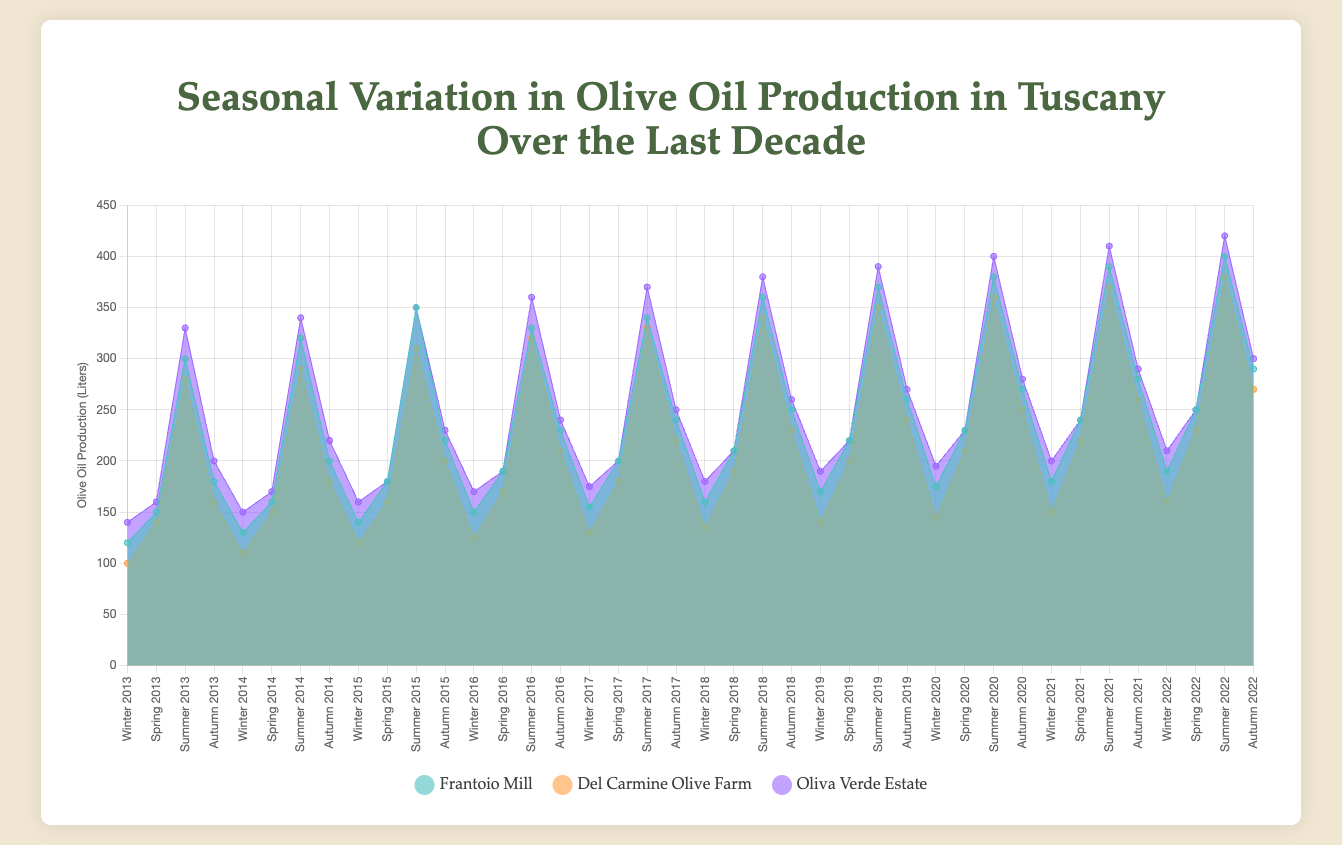What is the title of the chart? The title is displayed at the top of the chart area. It reads "Seasonal Variation in Olive Oil Production in Tuscany Over the Last Decade".
Answer: Seasonal Variation in Olive Oil Production in Tuscany Over the Last Decade Which olive farm had the highest production in Autumn 2022? Reviewing the chart, note the area corresponding to Autumn 2022 for each farm. The Oliva Verde Estate has the largest area for this period, indicating the highest production.
Answer: Oliva Verde Estate What are the axis labels in the chart? The x-axis has labels for each season-year combination (e.g., "Winter 2013"), and the y-axis is labeled "Olive Oil Production (Liters)".
Answer: Seasons and Years on x-axis, Olive Oil Production (Liters) on y-axis How does the olive oil production in Winter 2022 for Oliva Verde Estate compare to Winter 2013? To compare, locate the data points for Winter 2022 and Winter 2013 for Oliva Verde Estate. Winter 2022 has a production of 210 liters, while Winter 2013 has 140 liters, showing an increase.
Answer: Winter 2022 is higher by 70 liters Which season generally sees the highest olive oil production across all farms? Observing the seasonal patterns for each year, Summer consistently shows the highest production across all farms. The areas for Summer are repeatedly the largest.
Answer: Summer What was the average production in Summer over the last decade for Frantoio Mill? Sum the Summer values for each year (300 + 320 + 350 + 330 + 340 + 360 + 370 + 380 + 390 + 400 = 3540), then divide by the number of years (10).
Answer: 354 liters Between Del Carmine Olive Farm and Frantoio Mill, which had higher production in Spring 2017? Compare the Spring 2017 data points for both farms. Frantoio Mill produced 200 liters and Del Carmine Olive Farm produced 180 liters.
Answer: Frantoio Mill Compare the total production over the decade for Oliva Verde Estate and Del Carmine Olive Farm. Which one is higher? Sum all seasonal production values from 2013 to 2022 for both farms. For Oliva Verde Estate: 16200 liters; for Del Carmine Olive Farm: 11100 liters. Oliva Verde Estate has higher total production.
Answer: Oliva Verde Estate What trend is observed for the production at Frantoio Mill from 2013 to 2022? Reviewing Frantoio Mill's data from 2013 to 2022, we see a systematic increase in production across all seasons each subsequent year.
Answer: Increasing trend What is the median production in Spring for Del Carmine Olive Farm over the last decade? The Spring values are: 140, 150, 160, 170, 180, 190, 200, 210, 220, 230. The median value, being the 5th and 6th values in sorted order, is (180+190)/2.
Answer: 185 liters 